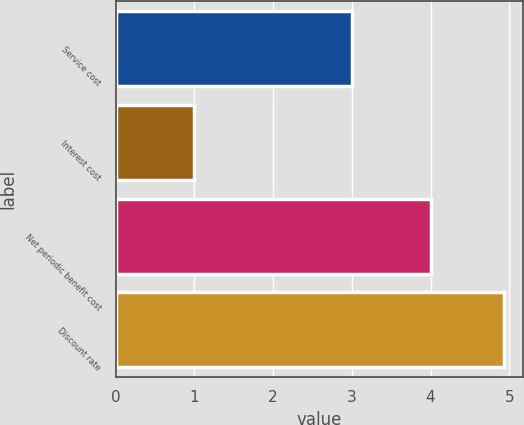Convert chart to OTSL. <chart><loc_0><loc_0><loc_500><loc_500><bar_chart><fcel>Service cost<fcel>Interest cost<fcel>Net periodic benefit cost<fcel>Discount rate<nl><fcel>3<fcel>1<fcel>4<fcel>4.93<nl></chart> 